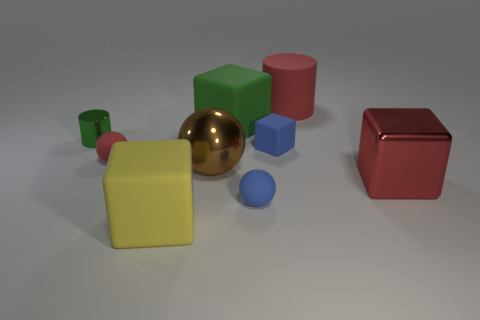Do the matte cylinder and the large shiny block have the same color?
Keep it short and to the point. Yes. Do the large matte object that is in front of the small blue block and the green metal object have the same shape?
Ensure brevity in your answer.  No. What shape is the small blue matte object behind the red matte ball?
Give a very brief answer. Cube. There is a matte thing that is the same color as the small rubber block; what size is it?
Provide a succinct answer. Small. What is the material of the small blue block?
Provide a succinct answer. Rubber. The shiny ball that is the same size as the yellow thing is what color?
Your answer should be very brief. Brown. The large thing that is the same color as the large matte cylinder is what shape?
Your response must be concise. Cube. Is the red metal thing the same shape as the yellow thing?
Provide a succinct answer. Yes. What is the big block that is both in front of the big green block and behind the small blue matte sphere made of?
Your answer should be compact. Metal. How big is the green rubber cube?
Provide a short and direct response. Large. 